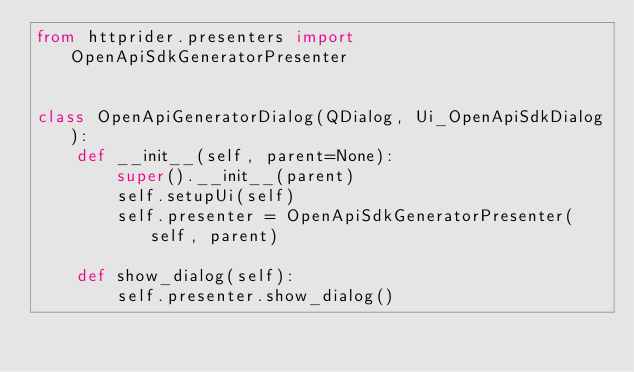<code> <loc_0><loc_0><loc_500><loc_500><_Python_>from httprider.presenters import OpenApiSdkGeneratorPresenter


class OpenApiGeneratorDialog(QDialog, Ui_OpenApiSdkDialog):
    def __init__(self, parent=None):
        super().__init__(parent)
        self.setupUi(self)
        self.presenter = OpenApiSdkGeneratorPresenter(self, parent)

    def show_dialog(self):
        self.presenter.show_dialog()
</code> 